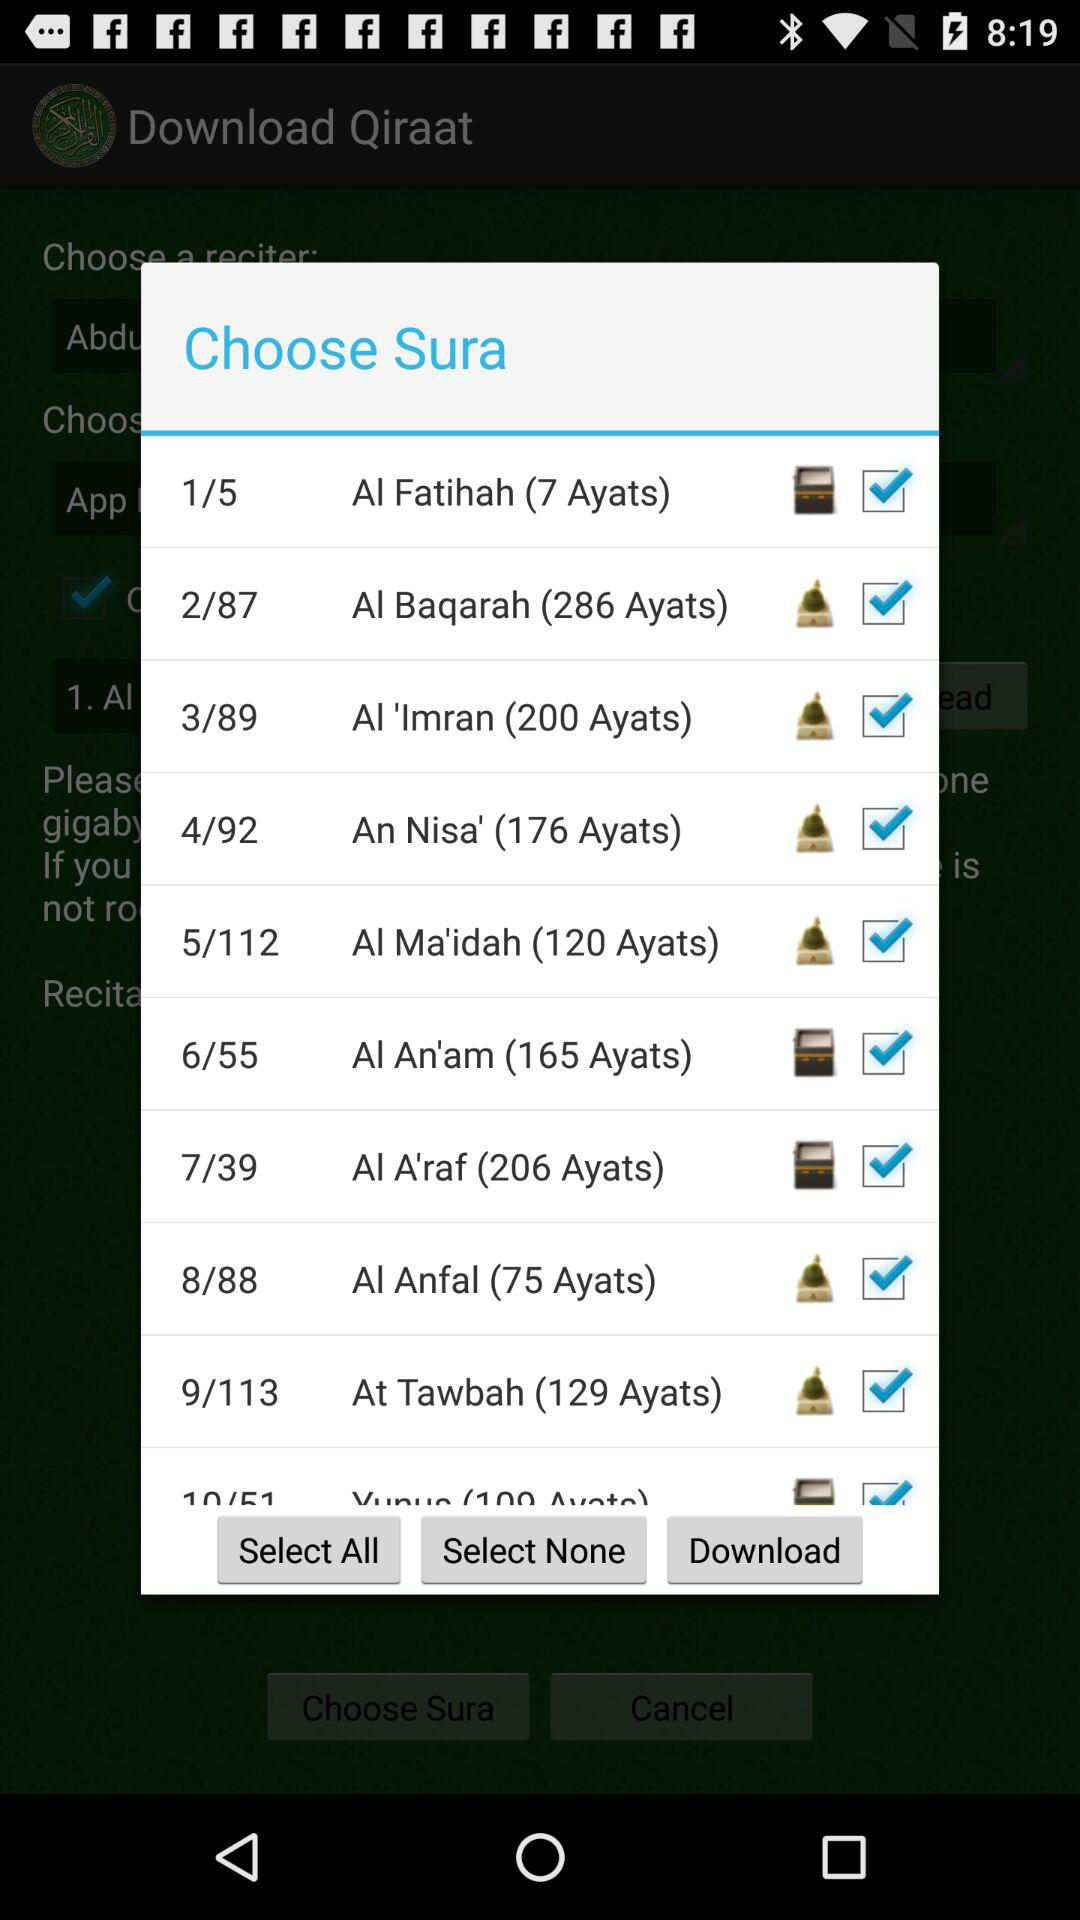Which suras are selected? The suras are "Al Fatihah (7 Ayats)", "Al Baqarah (286 Ayats)", "Al 'Imran (200 Ayats)", "An Nisa' (176 Ayats)", "Al Ma'idah (120 Ayats)", "Al An'am (165 Ayats)", "Al A'raf (206 Ayats)", "Al Anfal (75 Ayats)" and "At Tawbah (129 Ayats)". 